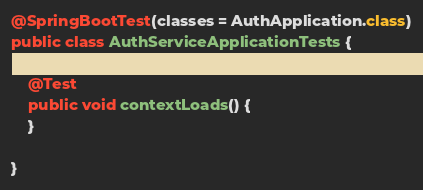Convert code to text. <code><loc_0><loc_0><loc_500><loc_500><_Java_>@SpringBootTest(classes = AuthApplication.class)
public class AuthServiceApplicationTests {

	@Test
	public void contextLoads() {
	}

}
</code> 